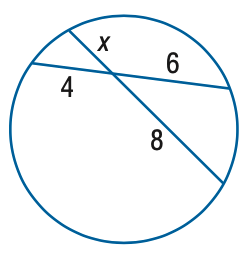Question: Find x.
Choices:
A. 3
B. 4
C. 5
D. 6
Answer with the letter. Answer: A 